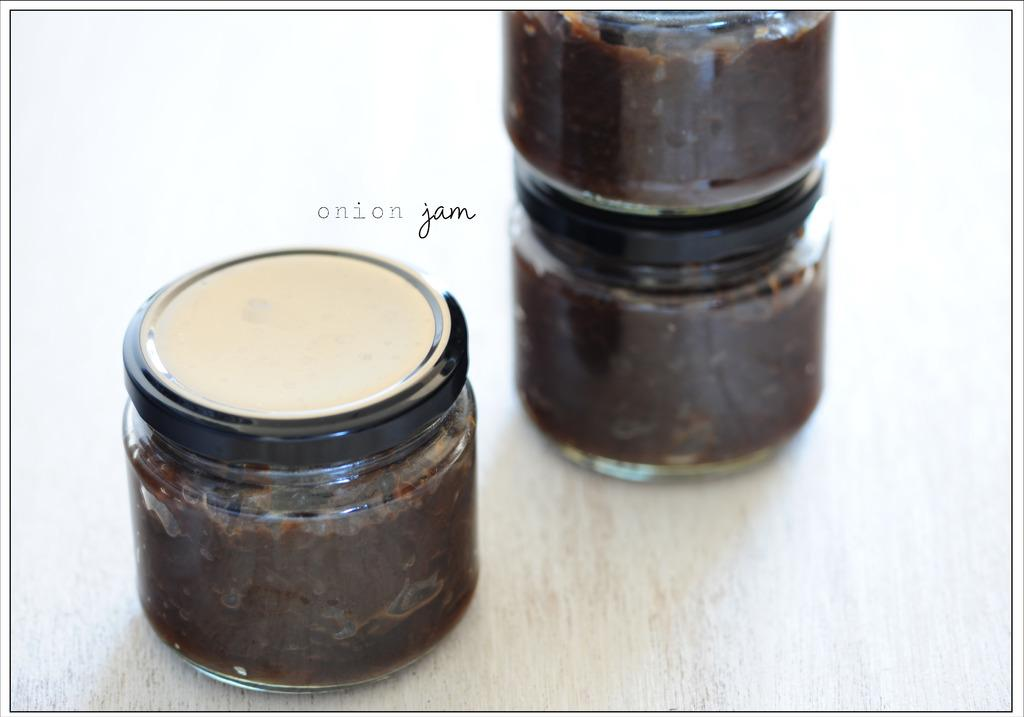<image>
Create a compact narrative representing the image presented. A container with brown stuff in it with two stacked behind it that says Onion Jam on the ad. 